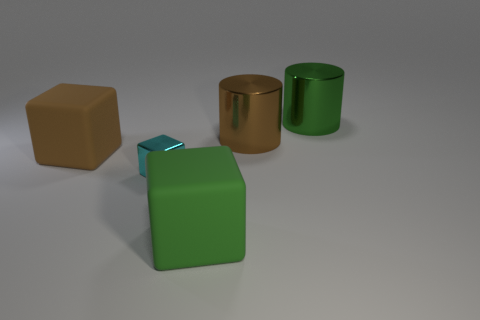Is there anything notable about the lighting in the scene? The lighting in the scene is soft and diffused, casting gentle shadows to the right of the objects. This indicates a single, possibly large light source coming from the left, giving the scene a calm and even tone. 